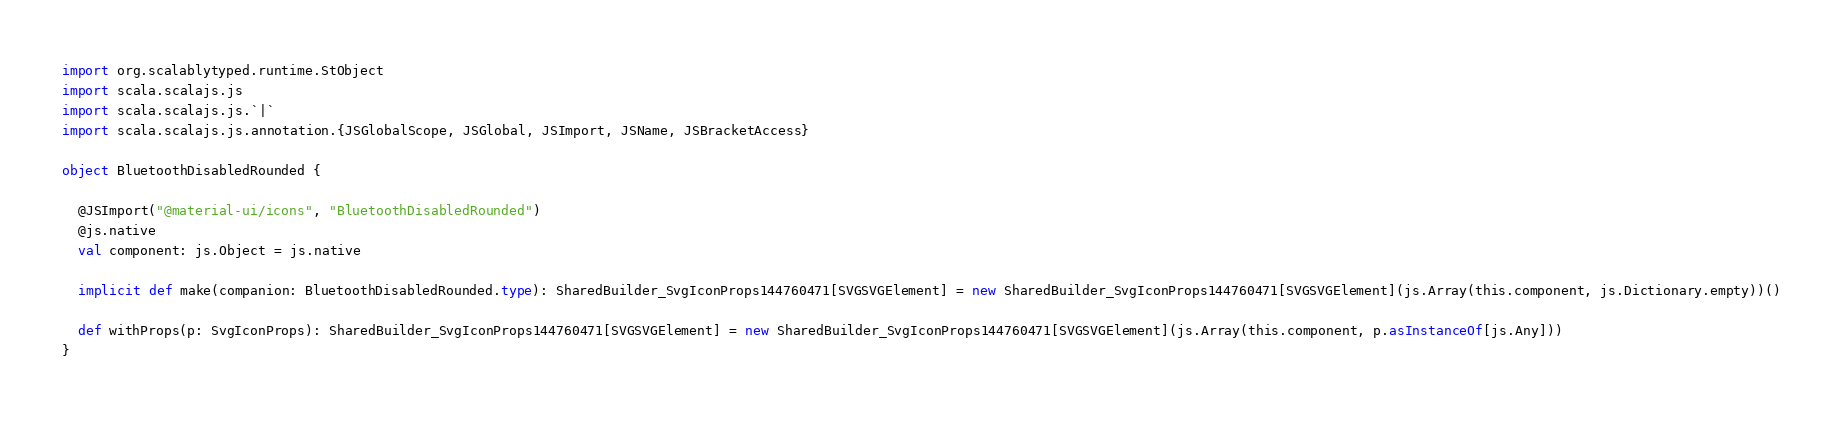<code> <loc_0><loc_0><loc_500><loc_500><_Scala_>import org.scalablytyped.runtime.StObject
import scala.scalajs.js
import scala.scalajs.js.`|`
import scala.scalajs.js.annotation.{JSGlobalScope, JSGlobal, JSImport, JSName, JSBracketAccess}

object BluetoothDisabledRounded {
  
  @JSImport("@material-ui/icons", "BluetoothDisabledRounded")
  @js.native
  val component: js.Object = js.native
  
  implicit def make(companion: BluetoothDisabledRounded.type): SharedBuilder_SvgIconProps144760471[SVGSVGElement] = new SharedBuilder_SvgIconProps144760471[SVGSVGElement](js.Array(this.component, js.Dictionary.empty))()
  
  def withProps(p: SvgIconProps): SharedBuilder_SvgIconProps144760471[SVGSVGElement] = new SharedBuilder_SvgIconProps144760471[SVGSVGElement](js.Array(this.component, p.asInstanceOf[js.Any]))
}
</code> 